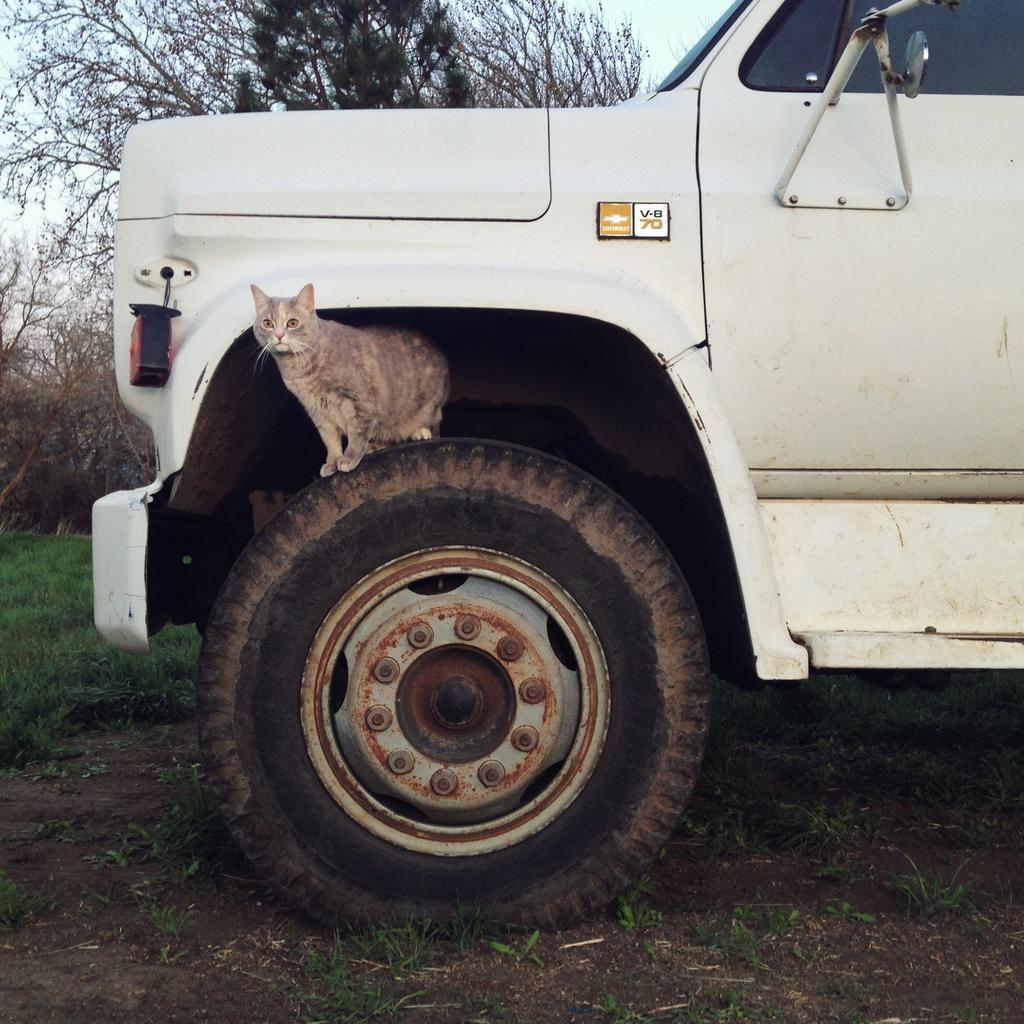Could you give a brief overview of what you see in this image? In this image there is a vehicle and we can see a cat on the tire. In the background there are trees and sky. At the bottom there is grass. 